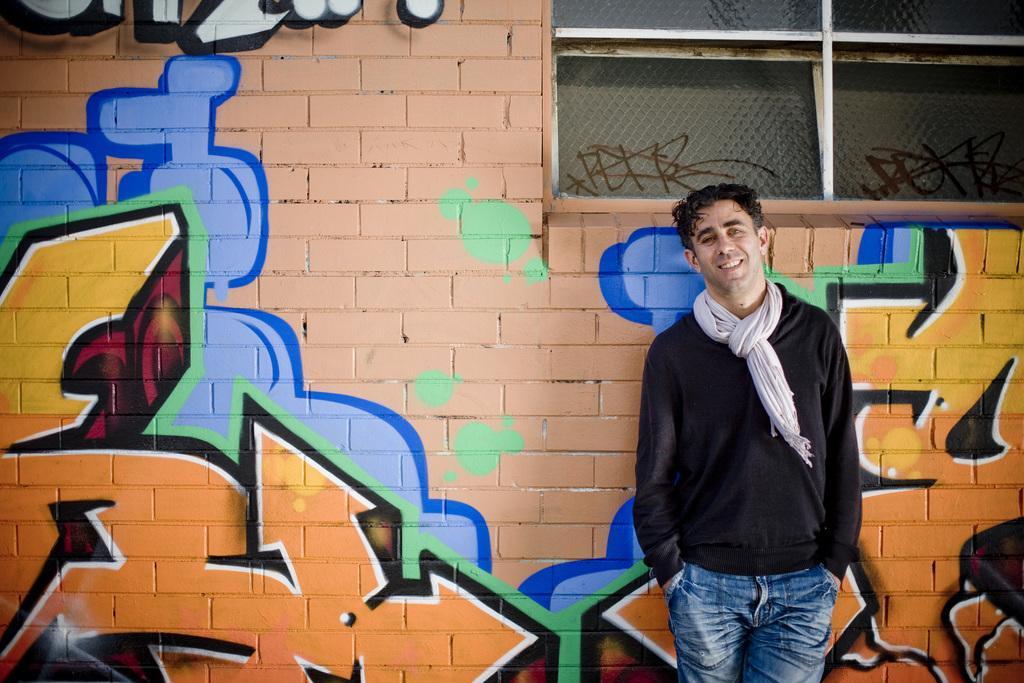Please provide a concise description of this image. In the image there is a man standing in front of a wall and on the wall there are some paintings. 